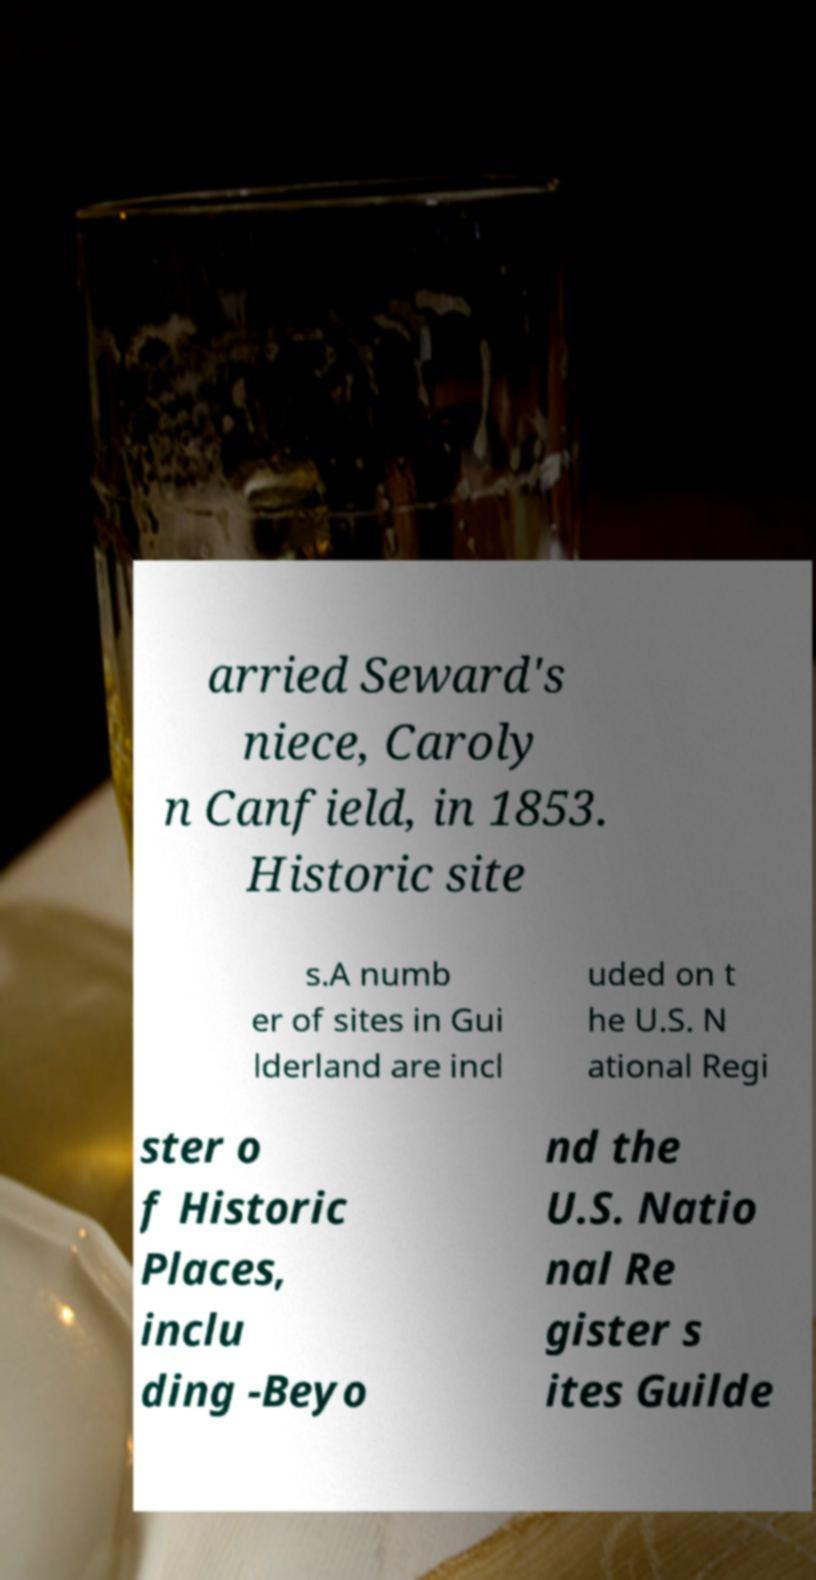Can you accurately transcribe the text from the provided image for me? arried Seward's niece, Caroly n Canfield, in 1853. Historic site s.A numb er of sites in Gui lderland are incl uded on t he U.S. N ational Regi ster o f Historic Places, inclu ding -Beyo nd the U.S. Natio nal Re gister s ites Guilde 